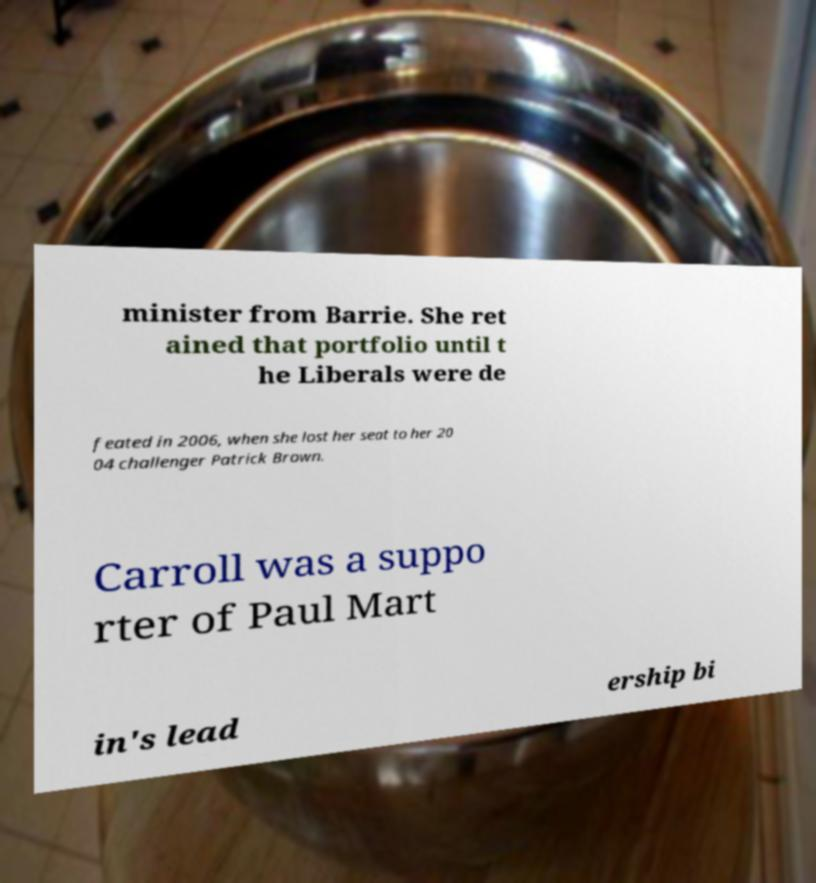What messages or text are displayed in this image? I need them in a readable, typed format. minister from Barrie. She ret ained that portfolio until t he Liberals were de feated in 2006, when she lost her seat to her 20 04 challenger Patrick Brown. Carroll was a suppo rter of Paul Mart in's lead ership bi 